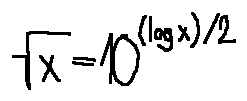<formula> <loc_0><loc_0><loc_500><loc_500>\sqrt { x } = 1 0 ^ { ( \log x ) / 2 }</formula> 